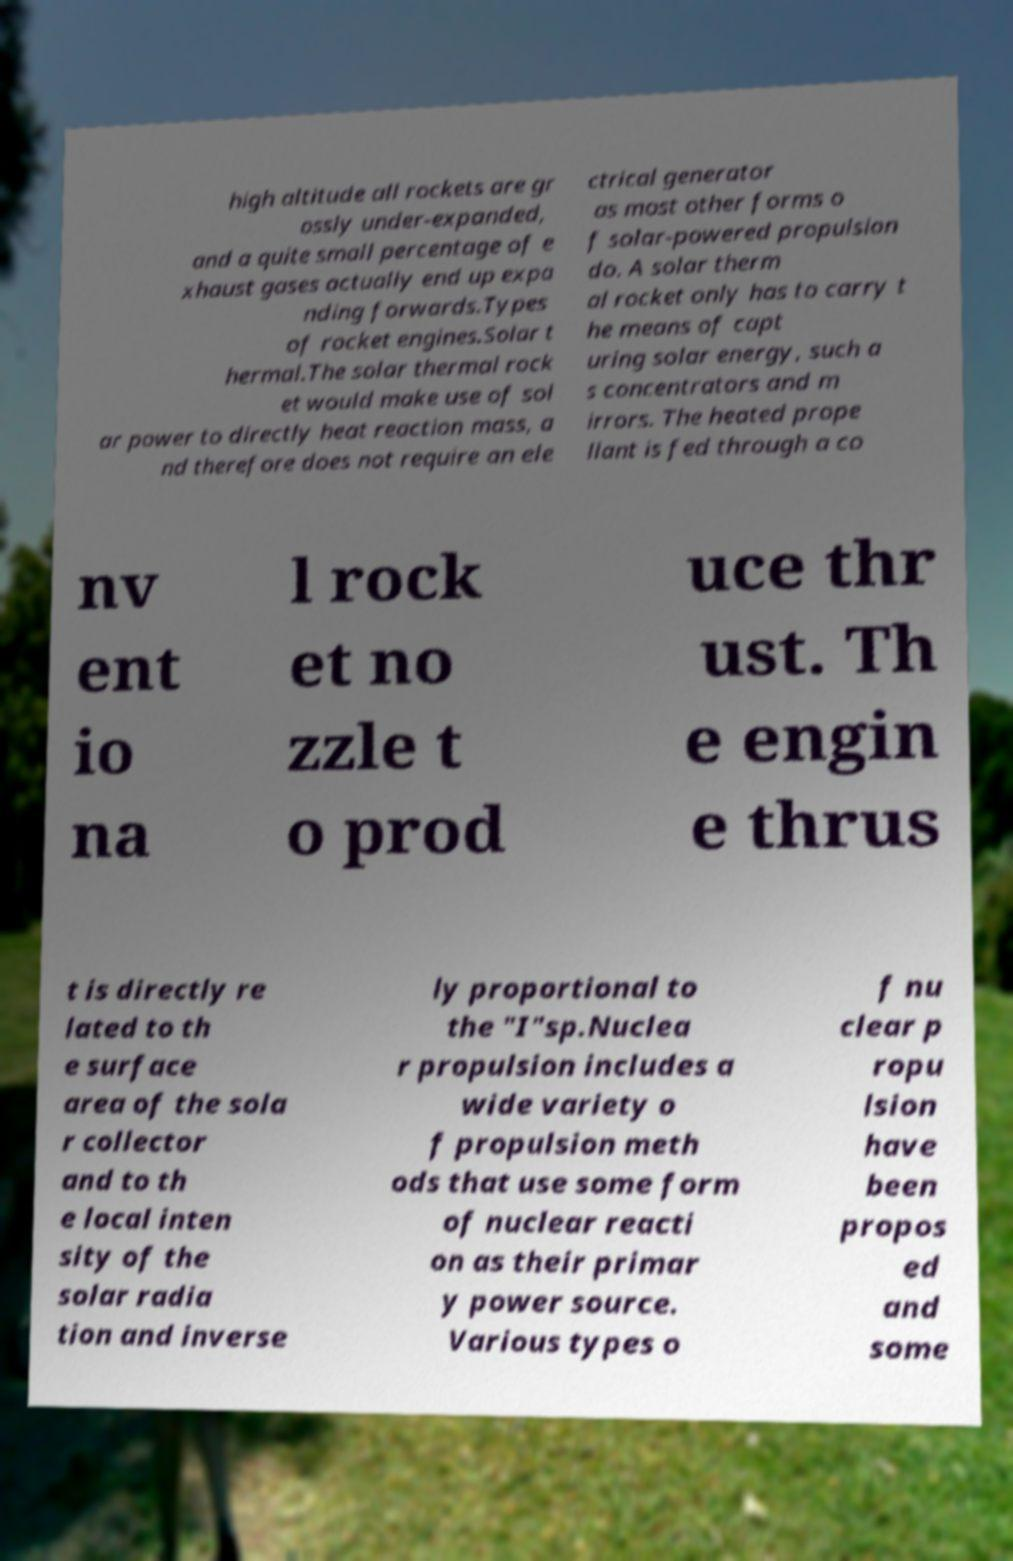Could you extract and type out the text from this image? high altitude all rockets are gr ossly under-expanded, and a quite small percentage of e xhaust gases actually end up expa nding forwards.Types of rocket engines.Solar t hermal.The solar thermal rock et would make use of sol ar power to directly heat reaction mass, a nd therefore does not require an ele ctrical generator as most other forms o f solar-powered propulsion do. A solar therm al rocket only has to carry t he means of capt uring solar energy, such a s concentrators and m irrors. The heated prope llant is fed through a co nv ent io na l rock et no zzle t o prod uce thr ust. Th e engin e thrus t is directly re lated to th e surface area of the sola r collector and to th e local inten sity of the solar radia tion and inverse ly proportional to the "I"sp.Nuclea r propulsion includes a wide variety o f propulsion meth ods that use some form of nuclear reacti on as their primar y power source. Various types o f nu clear p ropu lsion have been propos ed and some 